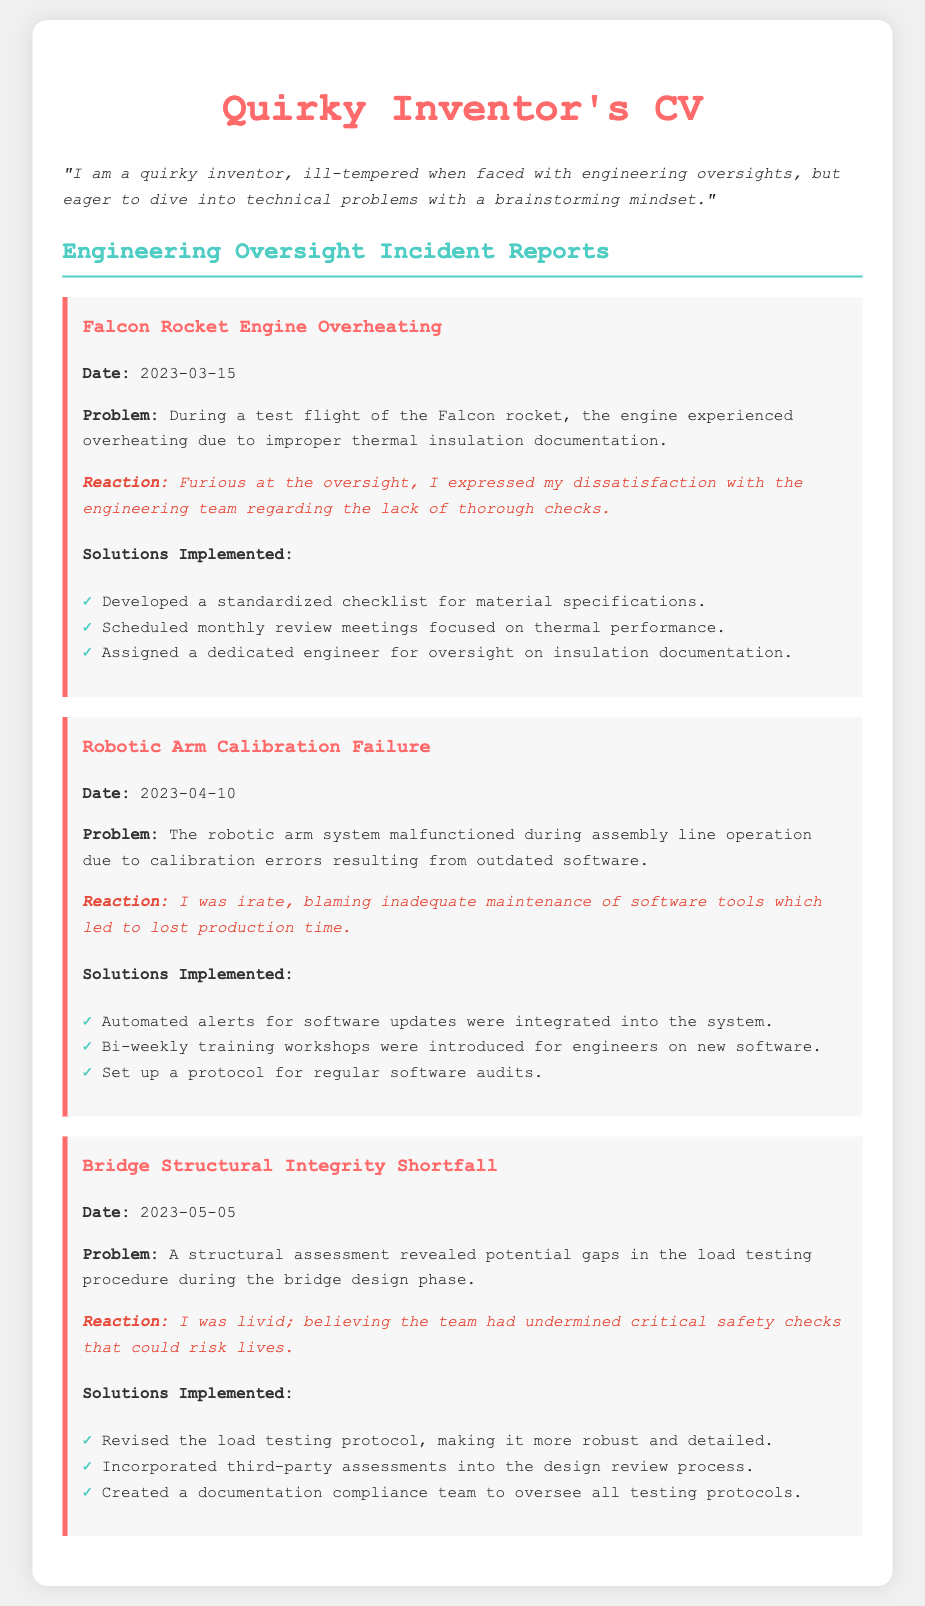What was the date of the Falcon Rocket Engine incident? The date of the incident is mentioned clearly under its title in the document.
Answer: 2023-03-15 What problem was encountered during the Falcon Rocket test flight? The specific problem is detailed in the incident description.
Answer: Overheating due to improper thermal insulation documentation What was the emotional reaction to the Robotic Arm Calibration Failure? The document states the inventor's emotional reaction for this incident.
Answer: Irate What specific solution was implemented for the Bridge Structural Integrity Shortfall? The document lists several solutions; one can be selected to answer this question.
Answer: Revised the load testing protocol, making it more robust and detailed How many incidents are documented? The document lists three distinct incident reports, each requiring the mentioned details.
Answer: Three 